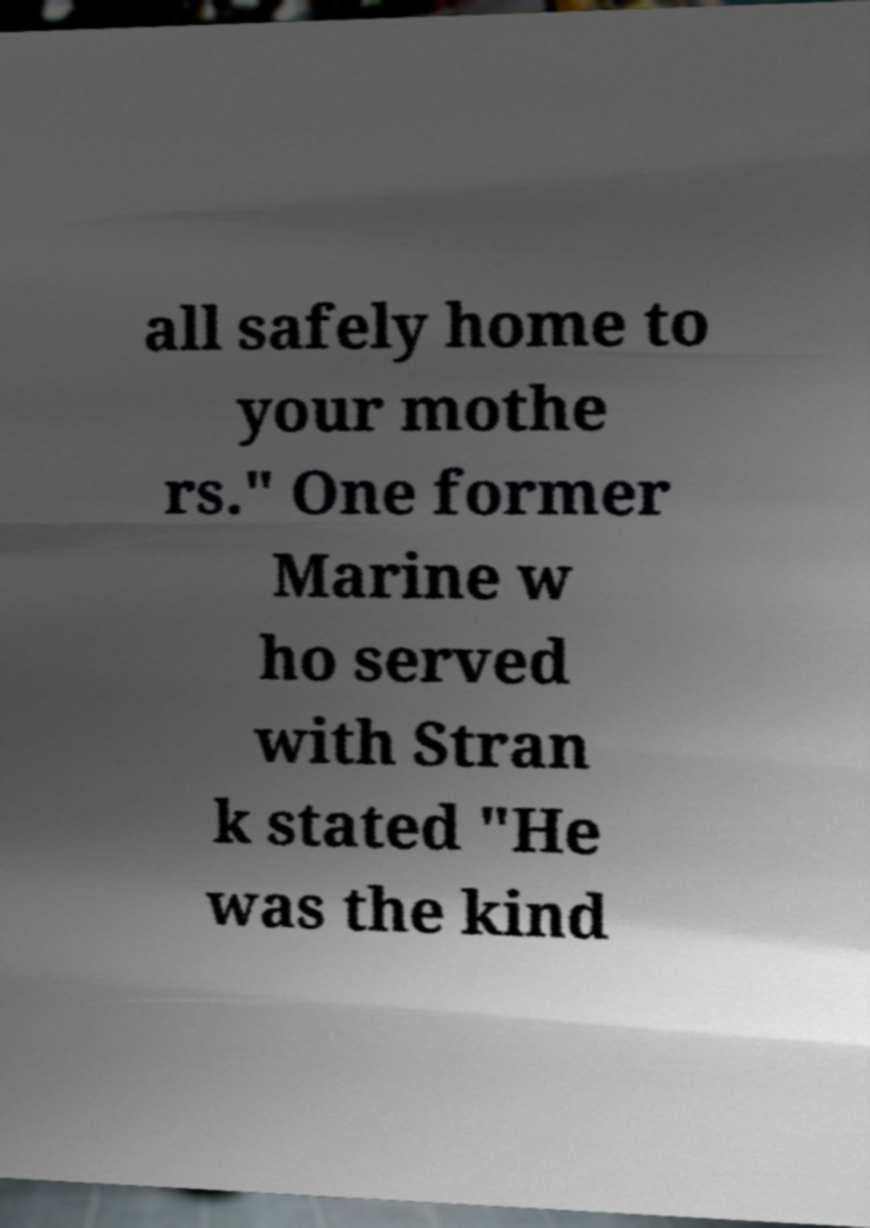There's text embedded in this image that I need extracted. Can you transcribe it verbatim? all safely home to your mothe rs." One former Marine w ho served with Stran k stated "He was the kind 